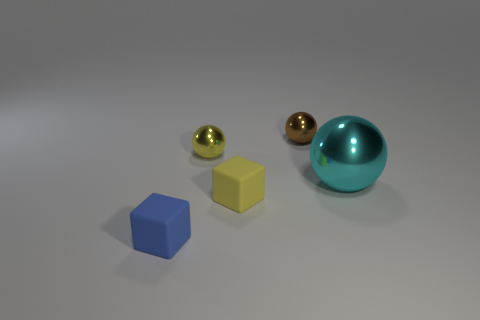Subtract all big cyan metal balls. How many balls are left? 2 Subtract all small cyan metal cubes. Subtract all tiny yellow matte blocks. How many objects are left? 4 Add 2 cubes. How many cubes are left? 4 Add 3 purple rubber things. How many purple rubber things exist? 3 Add 4 yellow rubber things. How many objects exist? 9 Subtract all cyan balls. How many balls are left? 2 Subtract 0 red blocks. How many objects are left? 5 Subtract all blocks. How many objects are left? 3 Subtract 2 blocks. How many blocks are left? 0 Subtract all brown blocks. Subtract all green balls. How many blocks are left? 2 